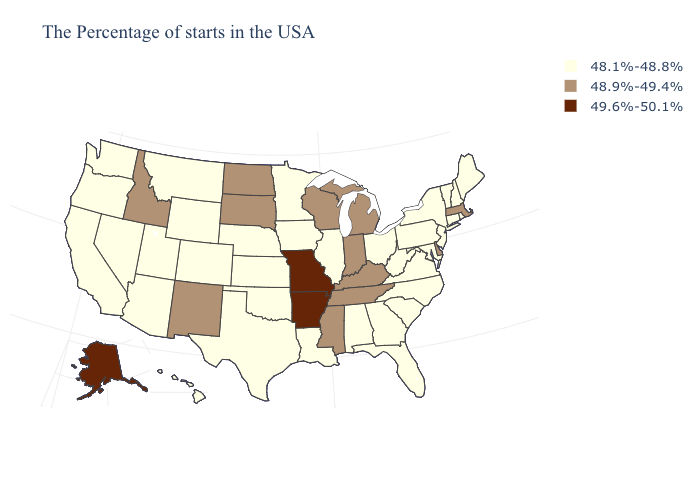Does Alaska have the highest value in the USA?
Answer briefly. Yes. How many symbols are there in the legend?
Short answer required. 3. Among the states that border Iowa , does Minnesota have the highest value?
Be succinct. No. What is the value of Delaware?
Be succinct. 48.9%-49.4%. Does South Dakota have the lowest value in the USA?
Short answer required. No. Name the states that have a value in the range 48.1%-48.8%?
Give a very brief answer. Maine, Rhode Island, New Hampshire, Vermont, Connecticut, New York, New Jersey, Maryland, Pennsylvania, Virginia, North Carolina, South Carolina, West Virginia, Ohio, Florida, Georgia, Alabama, Illinois, Louisiana, Minnesota, Iowa, Kansas, Nebraska, Oklahoma, Texas, Wyoming, Colorado, Utah, Montana, Arizona, Nevada, California, Washington, Oregon, Hawaii. What is the lowest value in states that border Massachusetts?
Short answer required. 48.1%-48.8%. Among the states that border Montana , does Wyoming have the lowest value?
Quick response, please. Yes. Does South Carolina have the lowest value in the South?
Quick response, please. Yes. Does Indiana have the lowest value in the USA?
Quick response, please. No. What is the highest value in the MidWest ?
Give a very brief answer. 49.6%-50.1%. What is the value of Nebraska?
Write a very short answer. 48.1%-48.8%. What is the value of North Carolina?
Concise answer only. 48.1%-48.8%. 